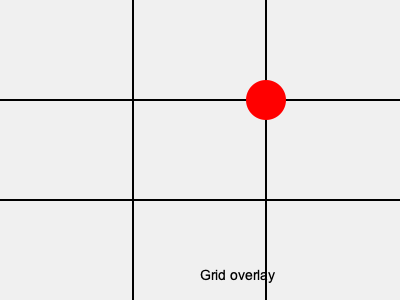In the context of Jorge Weisz's editing style, which intersection point of the Rule of Thirds grid is highlighted in red, and how might this placement affect the visual narrative of a scene? 1. The Rule of Thirds divides the frame into a 3x3 grid, creating nine equal sections.
2. The grid has four intersection points where the lines cross.
3. In this image, the red circle highlights the upper-right intersection point.
4. Jorge Weisz, known for his dynamic editing in Mexican cinema, often uses the Rule of Thirds to create visually compelling compositions.
5. Placing a subject or key element at this upper-right intersection can:
   a) Create visual tension or imbalance
   b) Draw the viewer's eye to that area of the frame
   c) Suggest movement or direction, especially if the subject is facing left
6. In Weisz's style, this placement might be used to:
   a) Emphasize a character's emotional state
   b) Foreshadow upcoming events or off-screen action
   c) Create a sense of space or environment around the subject
7. The upper-right placement can also imply power or dominance of a character or object in the scene.
Answer: Upper-right intersection 